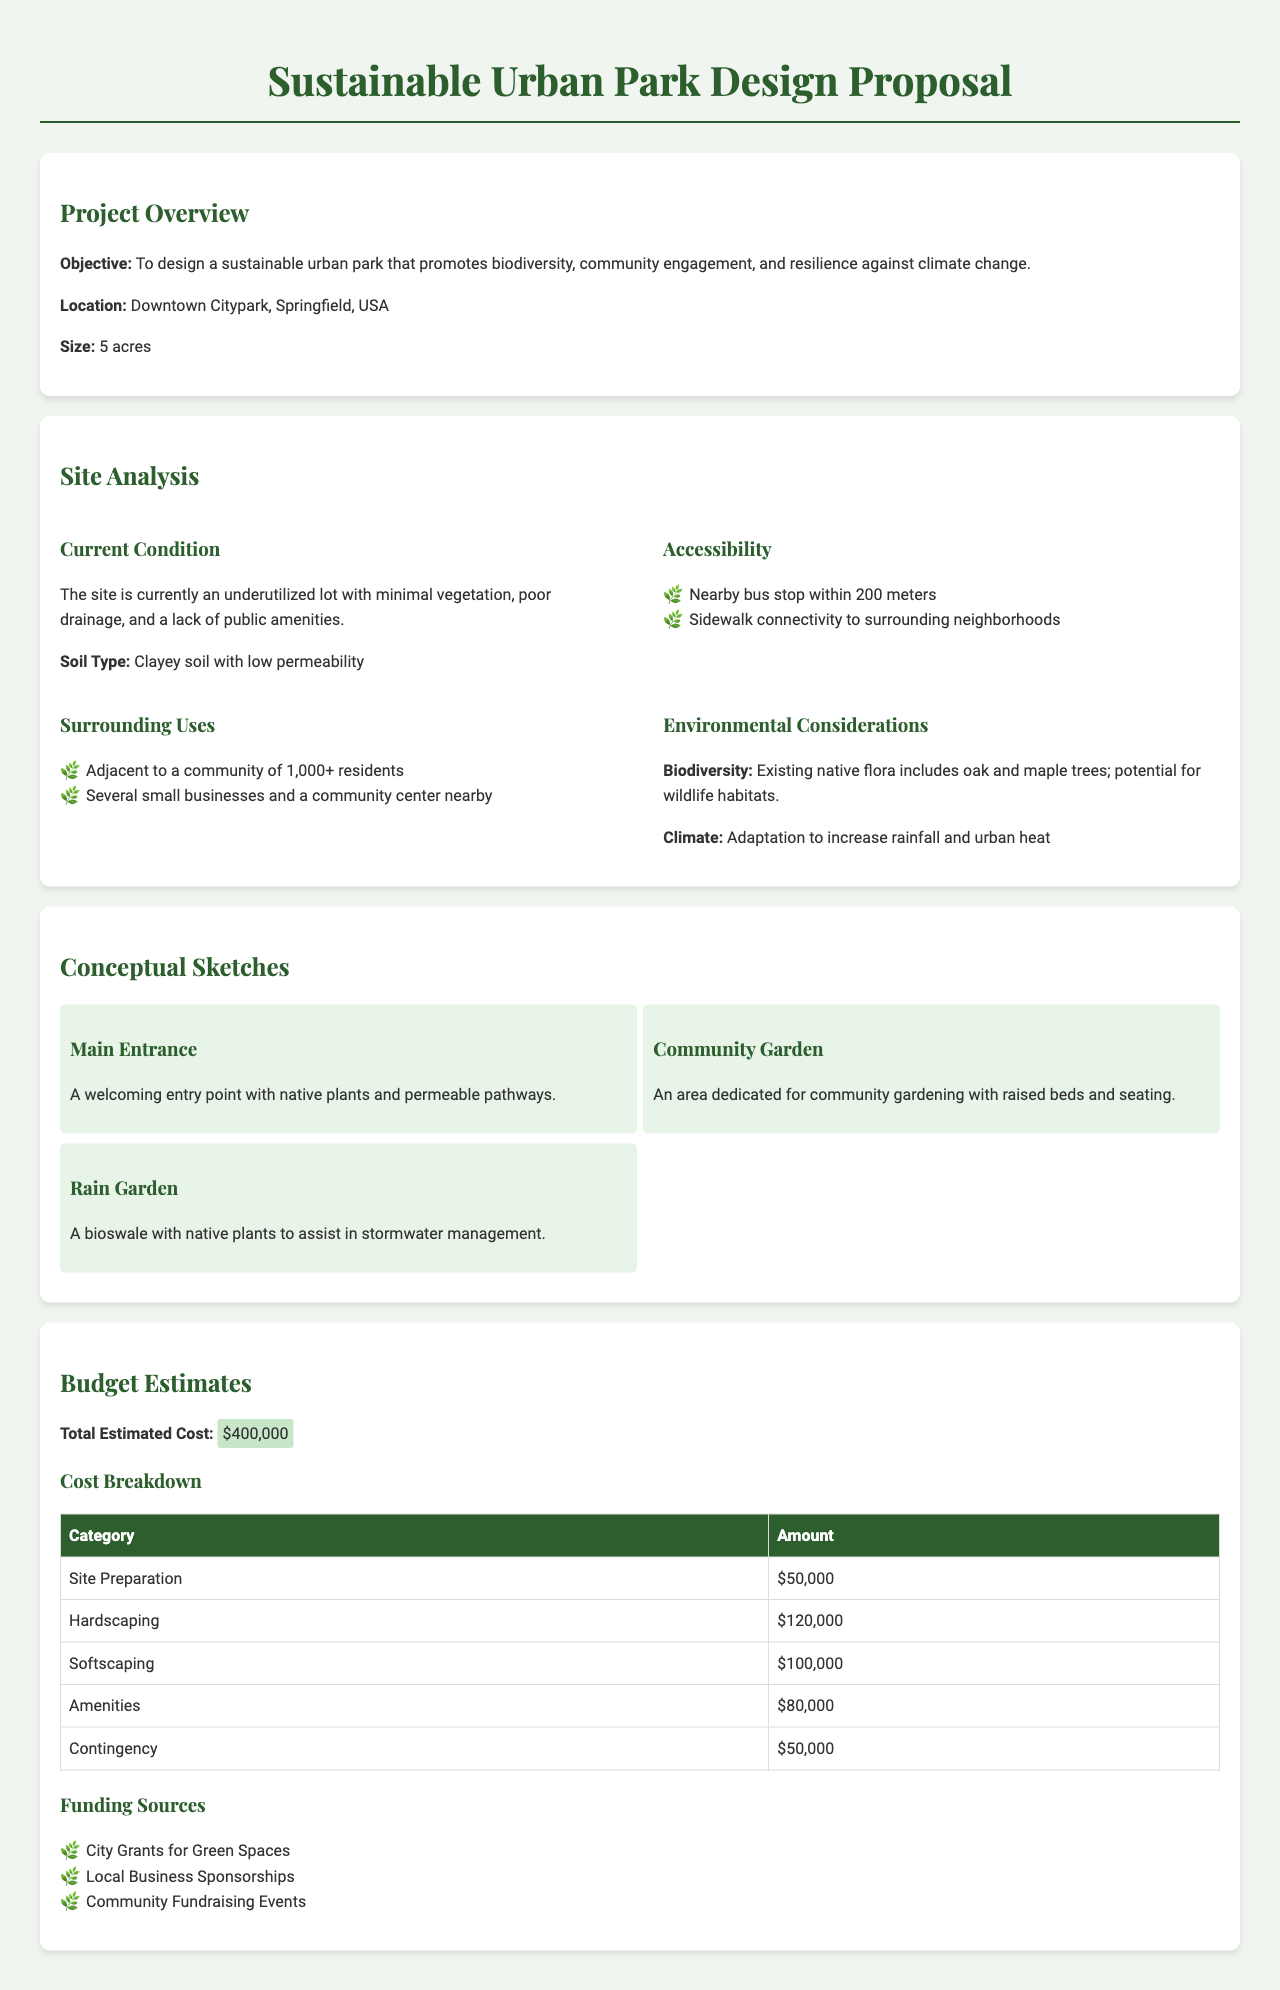what is the size of the park? The park is 5 acres in size as mentioned in the project overview.
Answer: 5 acres what type of soil is present? The document indicates that the soil type is clayey with low permeability in the site analysis section.
Answer: Clayey soil how much is allocated for hardscaping? The budget estimates section provides the amount allocated for hardscaping as $120,000.
Answer: $120,000 what environmental consideration is mentioned regarding biodiversity? The document states that existing native flora includes oak and maple trees, highlighting potential for wildlife habitats.
Answer: Oak and maple trees how many residents are nearby the park? The surrounding uses section indicates that the park is adjacent to a community of over 1,000 residents.
Answer: 1,000+ what is the total estimated cost of the project? Total estimated cost is presented in the budget estimates section as $400,000.
Answer: $400,000 what feature assists in stormwater management? The conceptual sketches section mentions a bioswale with native plants designed for stormwater management.
Answer: Rain Garden how many funding sources are listed? The budget estimates section lists three distinct funding sources for the project.
Answer: Three 